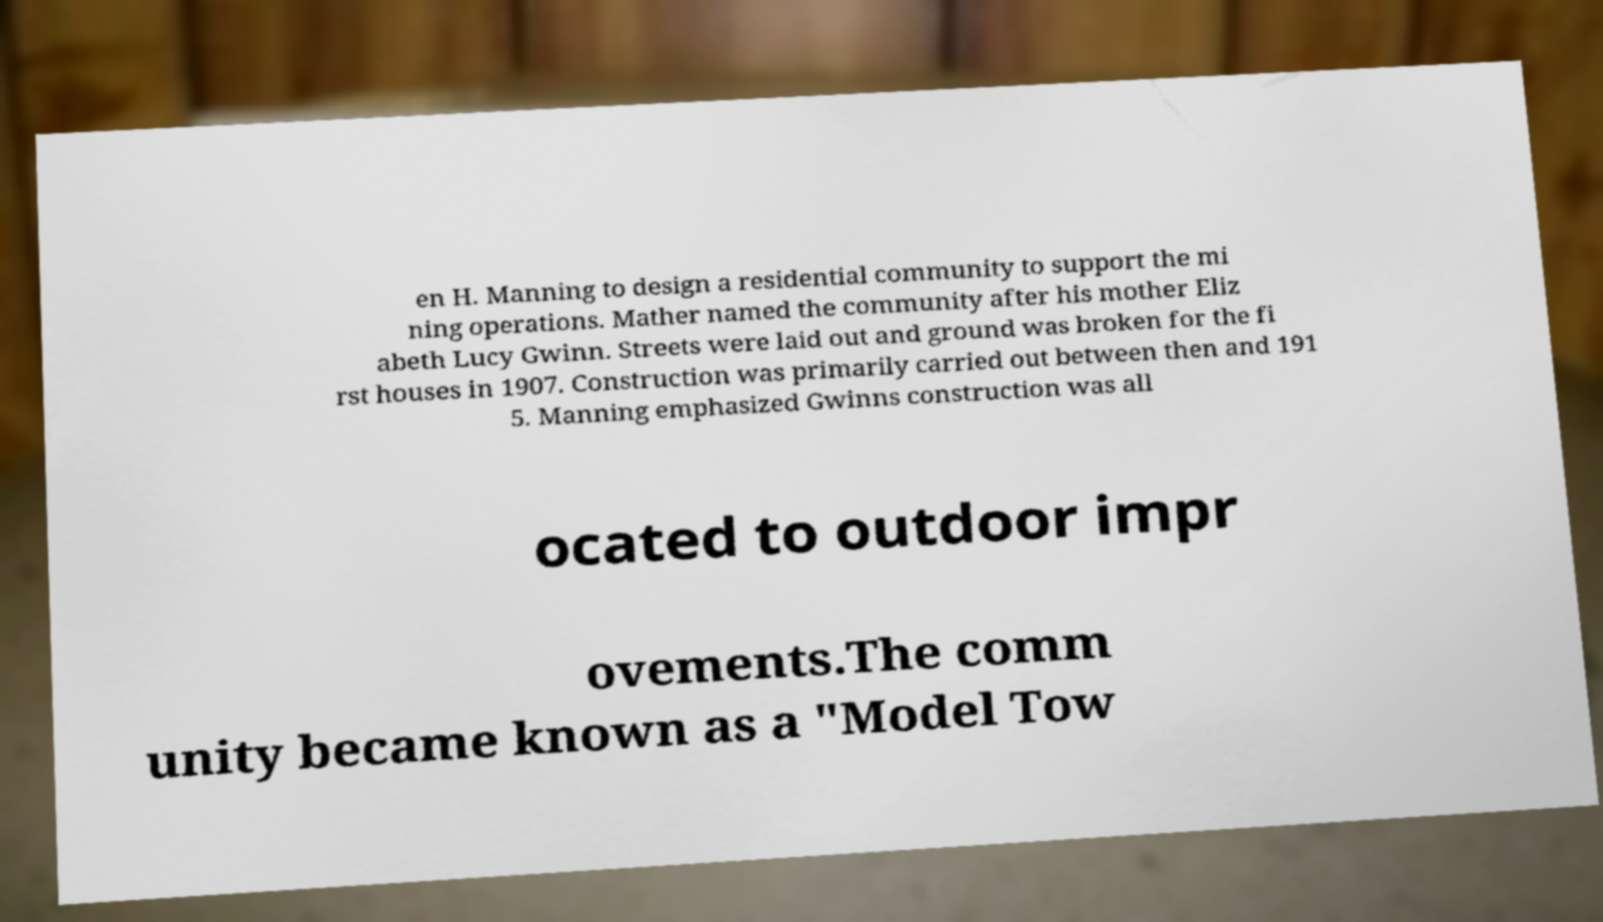Please read and relay the text visible in this image. What does it say? en H. Manning to design a residential community to support the mi ning operations. Mather named the community after his mother Eliz abeth Lucy Gwinn. Streets were laid out and ground was broken for the fi rst houses in 1907. Construction was primarily carried out between then and 191 5. Manning emphasized Gwinns construction was all ocated to outdoor impr ovements.The comm unity became known as a "Model Tow 